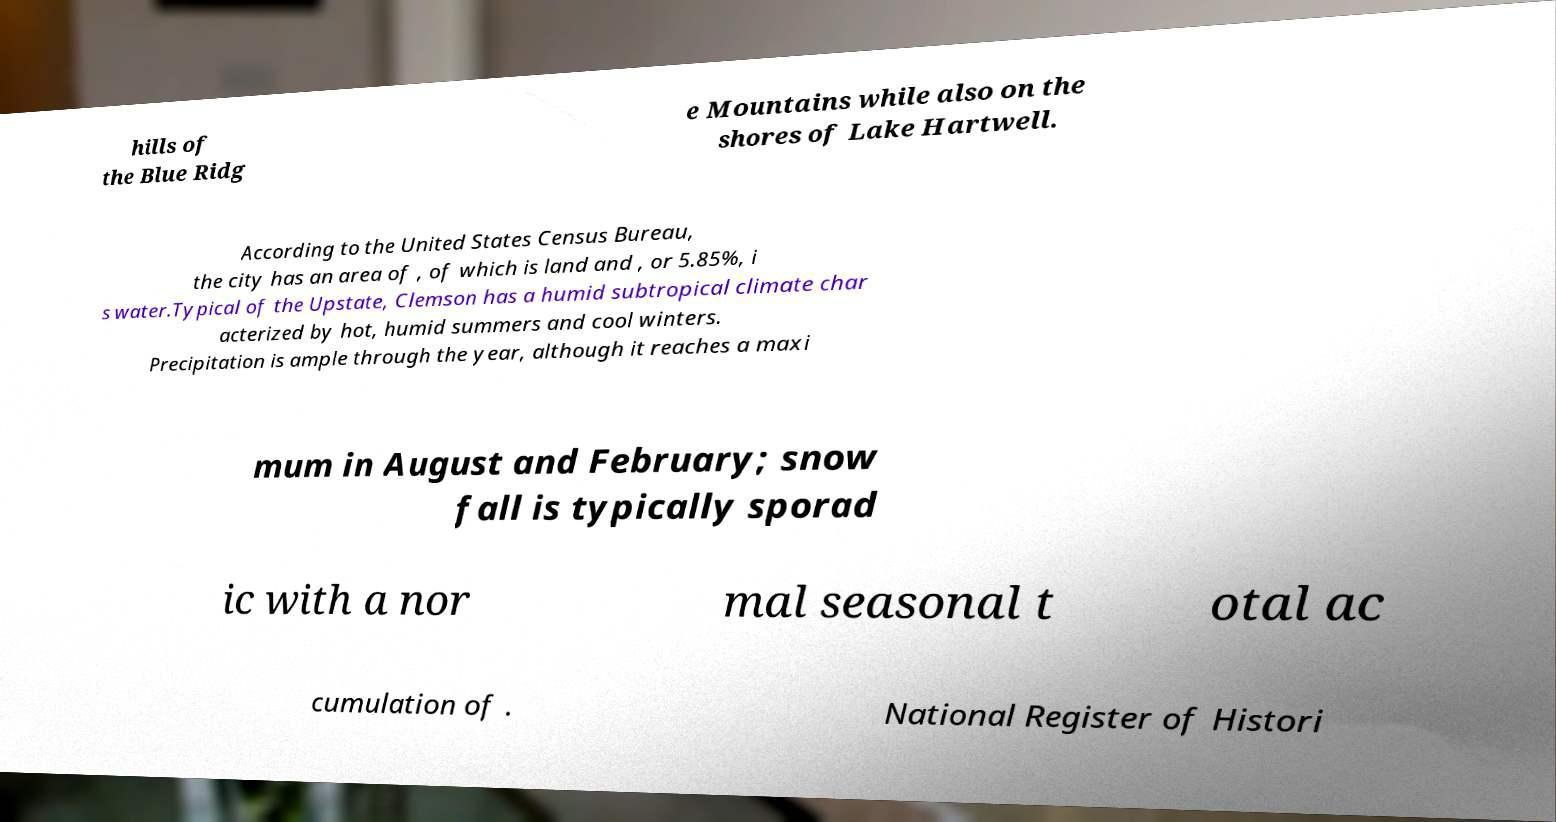There's text embedded in this image that I need extracted. Can you transcribe it verbatim? hills of the Blue Ridg e Mountains while also on the shores of Lake Hartwell. According to the United States Census Bureau, the city has an area of , of which is land and , or 5.85%, i s water.Typical of the Upstate, Clemson has a humid subtropical climate char acterized by hot, humid summers and cool winters. Precipitation is ample through the year, although it reaches a maxi mum in August and February; snow fall is typically sporad ic with a nor mal seasonal t otal ac cumulation of . National Register of Histori 